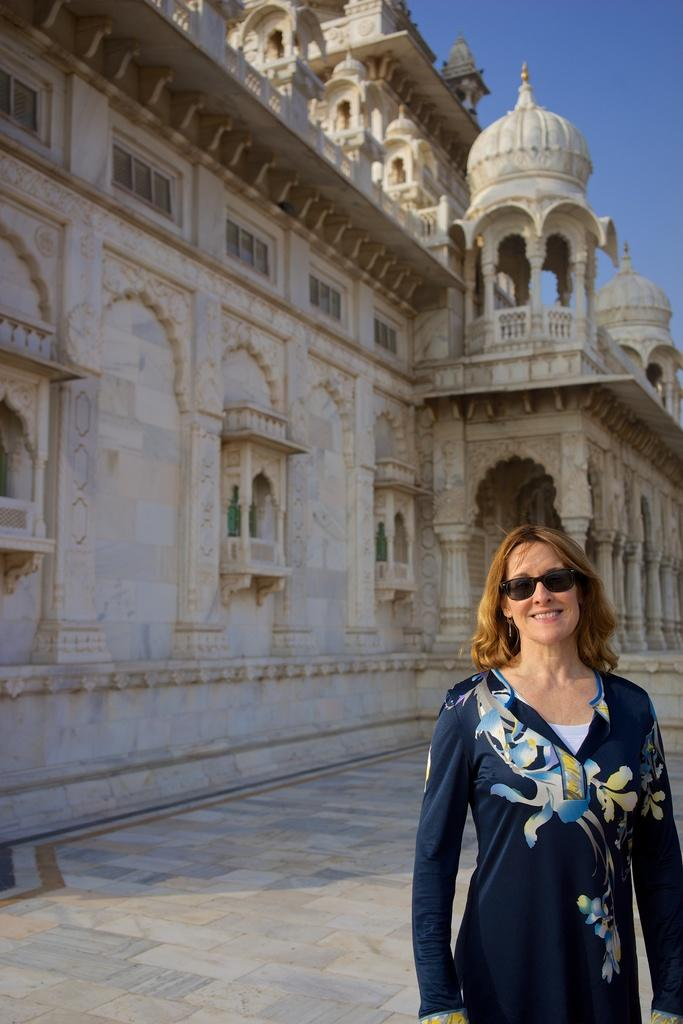What is the main subject of the image? There is a woman standing in the image. What is the woman's position in relation to the ground? The woman is standing on the floor. What can be seen in the background of the image? There is a building visible in the image. How many letters does the woman hold in her hand in the image? There is no mention of letters in the image, so it cannot be determined if the woman is holding any. 